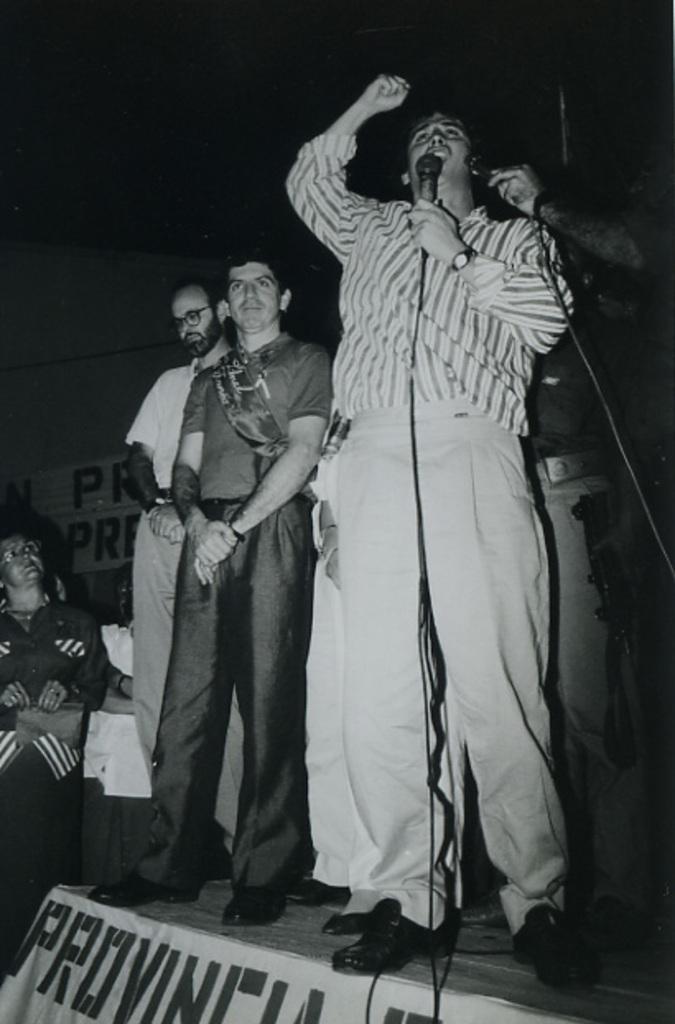In one or two sentences, can you explain what this image depicts? In this image I can see few people around. In front I can see a person is standing and holding mic. The image is in black and white. 